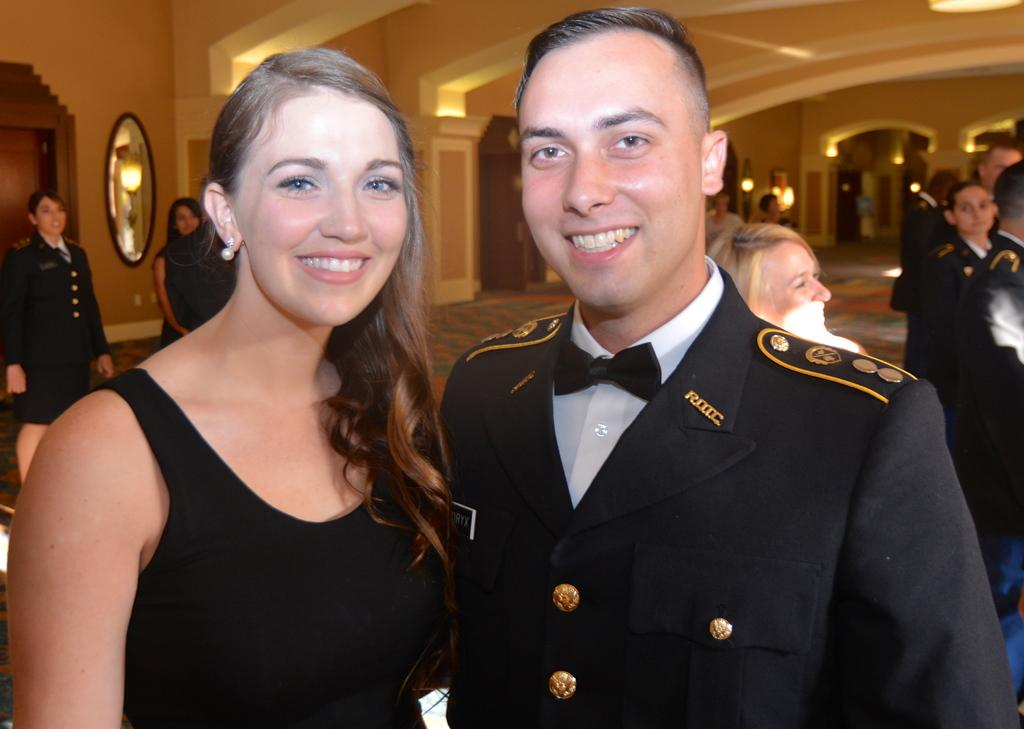What can be observed about the people in the image? There are people standing in the image, including a man and a woman. What is the facial expression of the man and the woman? The man and the woman are smiling in the image. What is a notable feature of the room in the image? There is a mirror on the wall in the image. What is the man wearing in the image? The man is wearing a coat and a bow tie. What type of arithmetic problem can be seen written on the jar in the image? There is no jar present in the image, and therefore no arithmetic problem can be observed. 